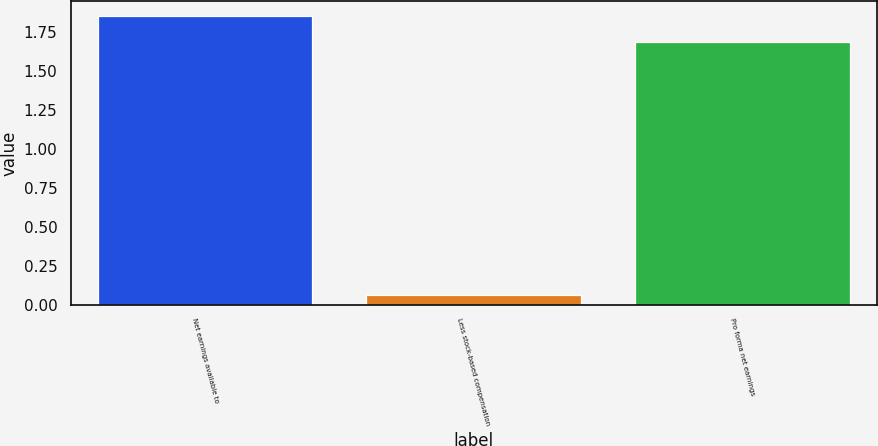Convert chart. <chart><loc_0><loc_0><loc_500><loc_500><bar_chart><fcel>Net earnings available to<fcel>Less stock-based compensation<fcel>Pro forma net earnings<nl><fcel>1.85<fcel>0.06<fcel>1.68<nl></chart> 